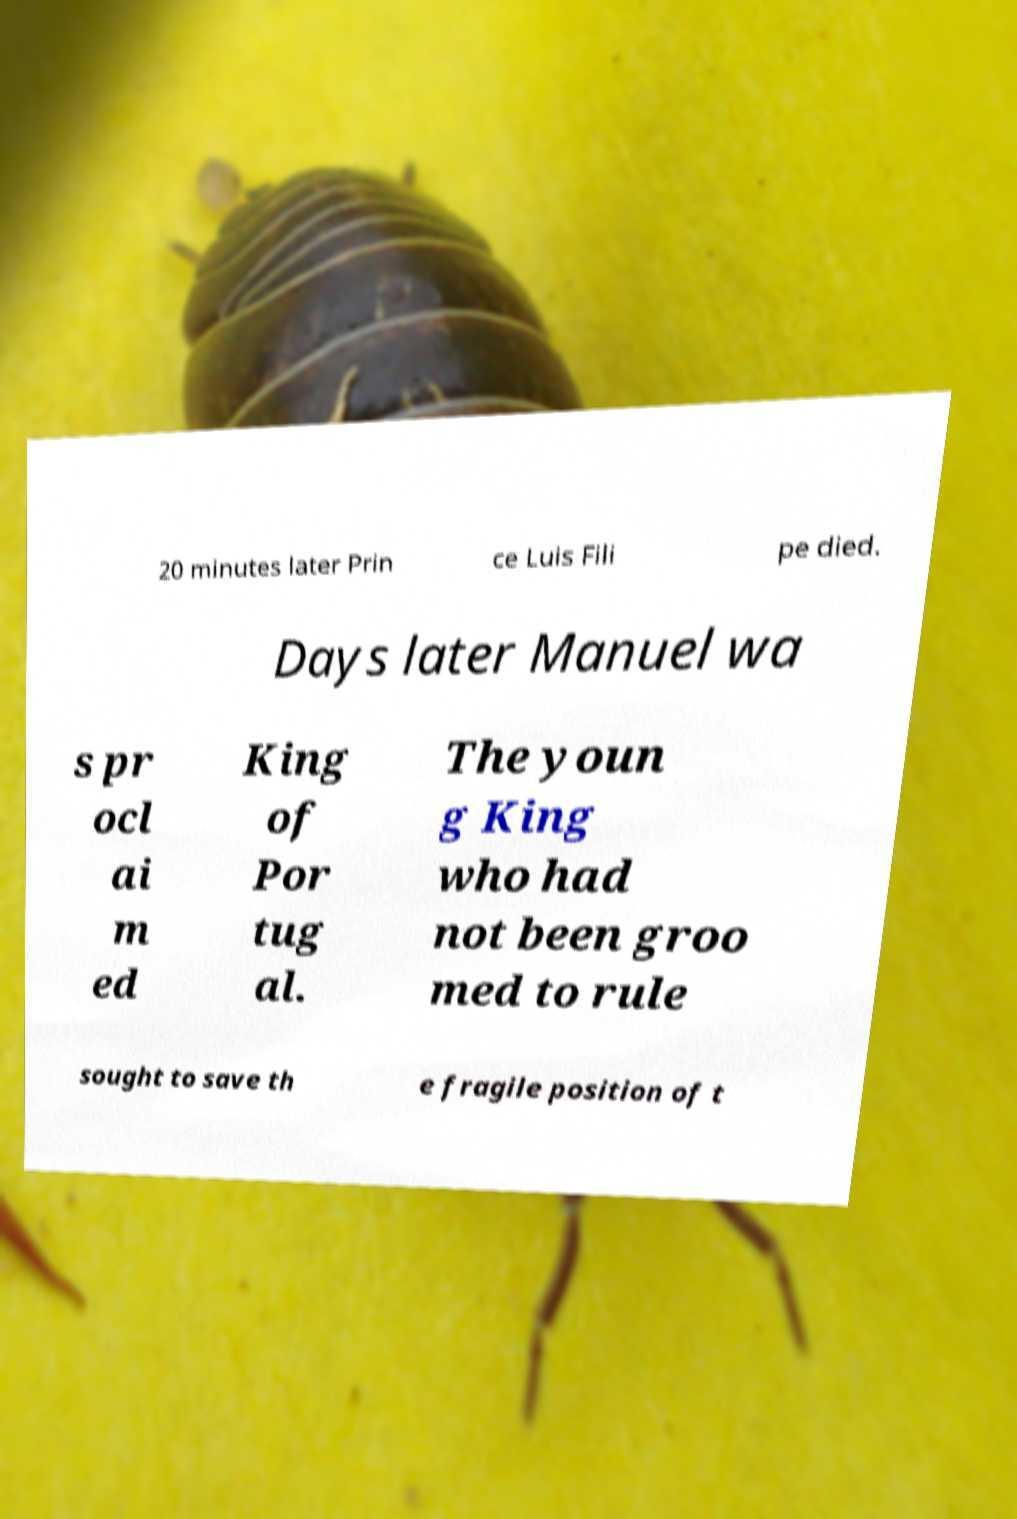Please identify and transcribe the text found in this image. 20 minutes later Prin ce Luis Fili pe died. Days later Manuel wa s pr ocl ai m ed King of Por tug al. The youn g King who had not been groo med to rule sought to save th e fragile position of t 